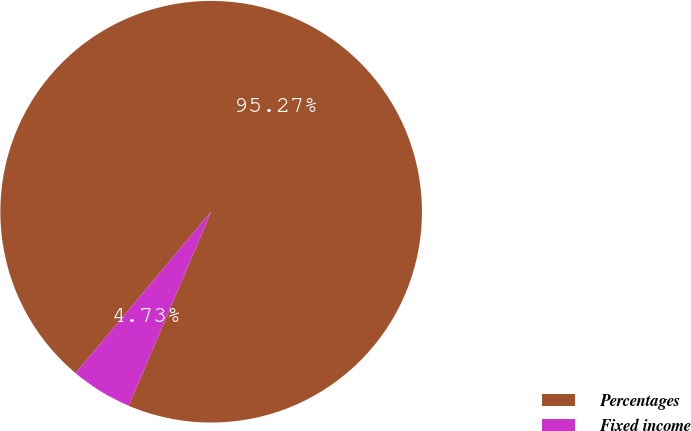Convert chart. <chart><loc_0><loc_0><loc_500><loc_500><pie_chart><fcel>Percentages<fcel>Fixed income<nl><fcel>95.27%<fcel>4.73%<nl></chart> 